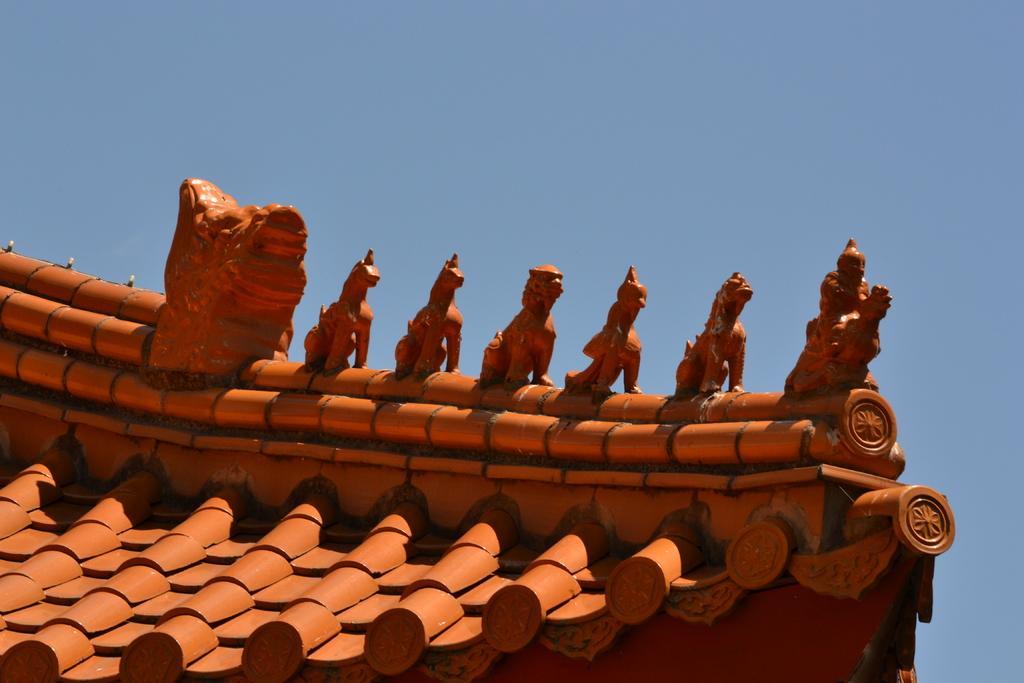Describe this image in one or two sentences. In this image we can see there are few structures on the top of clay roof. 